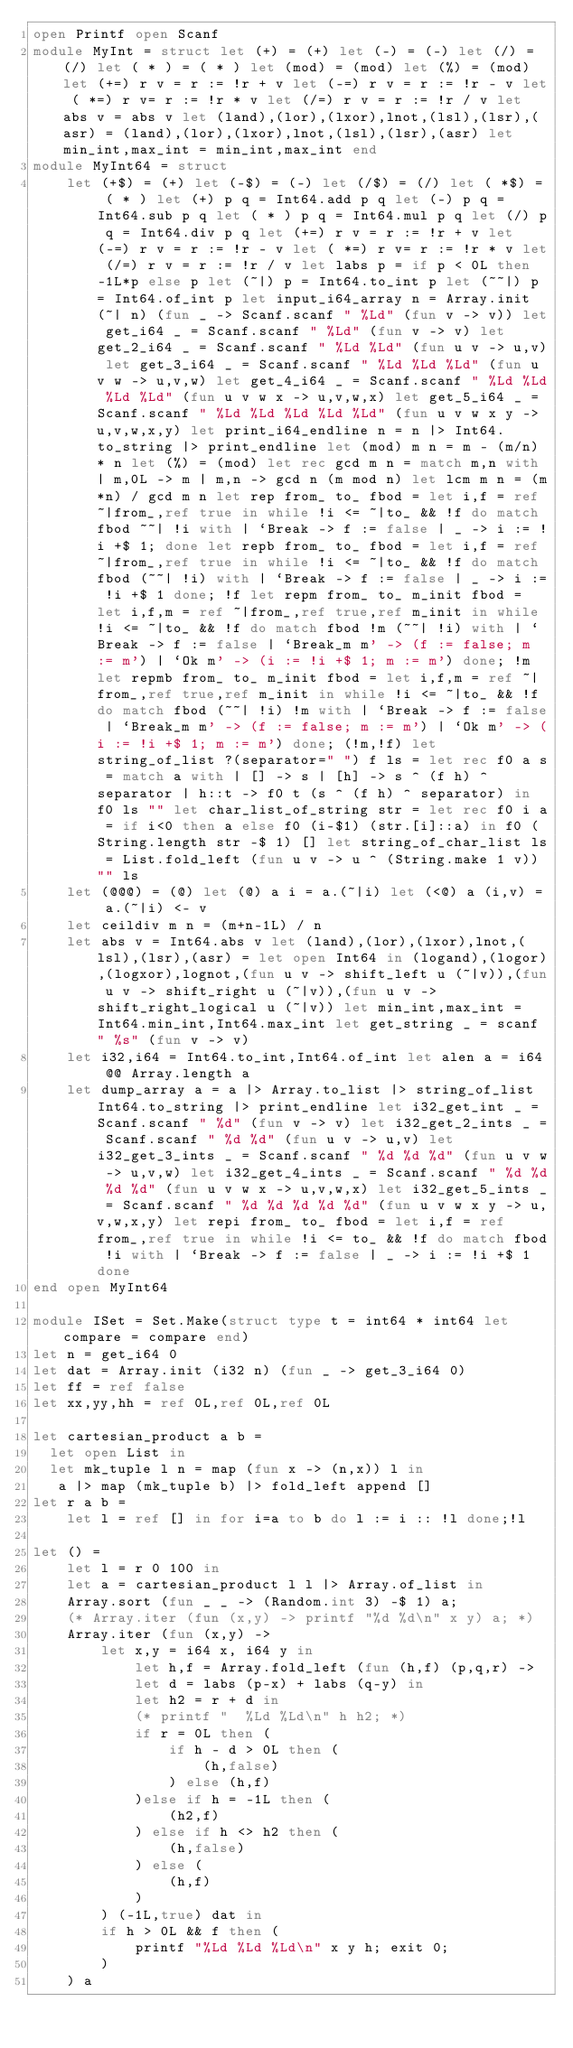<code> <loc_0><loc_0><loc_500><loc_500><_OCaml_>open Printf open Scanf
module MyInt = struct let (+) = (+) let (-) = (-) let (/) = (/) let ( * ) = ( * ) let (mod) = (mod) let (%) = (mod) let (+=) r v = r := !r + v let (-=) r v = r := !r - v let ( *=) r v= r := !r * v let (/=) r v = r := !r / v let abs v = abs v let (land),(lor),(lxor),lnot,(lsl),(lsr),(asr) = (land),(lor),(lxor),lnot,(lsl),(lsr),(asr) let min_int,max_int = min_int,max_int end
module MyInt64 = struct
	let (+$) = (+) let (-$) = (-) let (/$) = (/) let ( *$) = ( * ) let (+) p q = Int64.add p q let (-) p q = Int64.sub p q let ( * ) p q = Int64.mul p q let (/) p q = Int64.div p q let (+=) r v = r := !r + v let (-=) r v = r := !r - v let ( *=) r v= r := !r * v let (/=) r v = r := !r / v let labs p = if p < 0L then -1L*p else p let (~|) p = Int64.to_int p let (~~|) p = Int64.of_int p let input_i64_array n = Array.init (~| n) (fun _ -> Scanf.scanf " %Ld" (fun v -> v)) let get_i64 _ = Scanf.scanf " %Ld" (fun v -> v) let get_2_i64 _ = Scanf.scanf " %Ld %Ld" (fun u v -> u,v) let get_3_i64 _ = Scanf.scanf " %Ld %Ld %Ld" (fun u v w -> u,v,w) let get_4_i64 _ = Scanf.scanf " %Ld %Ld %Ld %Ld" (fun u v w x -> u,v,w,x) let get_5_i64 _ = Scanf.scanf " %Ld %Ld %Ld %Ld %Ld" (fun u v w x y -> u,v,w,x,y) let print_i64_endline n = n |> Int64.to_string |> print_endline let (mod) m n = m - (m/n) * n let (%) = (mod) let rec gcd m n = match m,n with | m,0L -> m | m,n -> gcd n (m mod n) let lcm m n = (m*n) / gcd m n let rep from_ to_ fbod = let i,f = ref ~|from_,ref true in while !i <= ~|to_ && !f do match fbod ~~| !i with | `Break -> f := false | _ -> i := !i +$ 1; done let repb from_ to_ fbod = let i,f = ref ~|from_,ref true in while !i <= ~|to_ && !f do match fbod (~~| !i) with | `Break -> f := false | _ -> i := !i +$ 1 done; !f let repm from_ to_ m_init fbod = let i,f,m = ref ~|from_,ref true,ref m_init in while !i <= ~|to_ && !f do match fbod !m (~~| !i) with | `Break -> f := false | `Break_m m' -> (f := false; m := m') | `Ok m' -> (i := !i +$ 1; m := m') done; !m let repmb from_ to_ m_init fbod = let i,f,m = ref ~|from_,ref true,ref m_init in while !i <= ~|to_ && !f do match fbod (~~| !i) !m with | `Break -> f := false | `Break_m m' -> (f := false; m := m') | `Ok m' -> (i := !i +$ 1; m := m') done; (!m,!f) let string_of_list ?(separator=" ") f ls = let rec f0 a s = match a with | [] -> s | [h] -> s ^ (f h) ^ separator | h::t -> f0 t (s ^ (f h) ^ separator) in f0 ls "" let char_list_of_string str = let rec f0 i a = if i<0 then a else f0 (i-$1) (str.[i]::a) in f0 (String.length str -$ 1) [] let string_of_char_list ls = List.fold_left (fun u v -> u ^ (String.make 1 v)) "" ls
	let (@@@) = (@) let (@) a i = a.(~|i) let (<@) a (i,v) = a.(~|i) <- v
	let ceildiv m n = (m+n-1L) / n
	let abs v = Int64.abs v let (land),(lor),(lxor),lnot,(lsl),(lsr),(asr) = let open Int64 in (logand),(logor),(logxor),lognot,(fun u v -> shift_left u (~|v)),(fun u v -> shift_right u (~|v)),(fun u v -> shift_right_logical u (~|v)) let min_int,max_int = Int64.min_int,Int64.max_int let get_string _ = scanf " %s" (fun v -> v)
	let i32,i64 = Int64.to_int,Int64.of_int let alen a = i64 @@ Array.length a
	let dump_array a = a |> Array.to_list |> string_of_list Int64.to_string |> print_endline let i32_get_int _ = Scanf.scanf " %d" (fun v -> v) let i32_get_2_ints _ = Scanf.scanf " %d %d" (fun u v -> u,v) let i32_get_3_ints _ = Scanf.scanf " %d %d %d" (fun u v w -> u,v,w) let i32_get_4_ints _ = Scanf.scanf " %d %d %d %d" (fun u v w x -> u,v,w,x) let i32_get_5_ints _ = Scanf.scanf " %d %d %d %d %d" (fun u v w x y -> u,v,w,x,y) let repi from_ to_ fbod = let i,f = ref from_,ref true in while !i <= to_ && !f do match fbod !i with | `Break -> f := false | _ -> i := !i +$ 1 done
end open MyInt64

module ISet = Set.Make(struct type t = int64 * int64 let compare = compare end)
let n = get_i64 0
let dat = Array.init (i32 n) (fun _ -> get_3_i64 0) 
let ff = ref false 
let xx,yy,hh = ref 0L,ref 0L,ref 0L 

let cartesian_product a b =
  let open List in
  let mk_tuple l n = map (fun x -> (n,x)) l in  
   a |> map (mk_tuple b) |> fold_left append []
let r a b =
	let l = ref [] in for i=a to b do l := i :: !l done;!l

let () =
	let l = r 0 100 in
	let a = cartesian_product l l |> Array.of_list in
	Array.sort (fun _ _ -> (Random.int 3) -$ 1) a;
	(* Array.iter (fun (x,y) -> printf "%d %d\n" x y) a; *)
	Array.iter (fun (x,y) ->
		let x,y = i64 x, i64 y in
			let h,f = Array.fold_left (fun (h,f) (p,q,r) ->
			let d = labs (p-x) + labs (q-y) in
			let h2 = r + d in
			(* printf "  %Ld %Ld\n" h h2; *)
			if r = 0L then (
				if h - d > 0L then (
					(h,false)
				) else (h,f)
			)else if h = -1L then (
				(h2,f)
			) else if h <> h2 then (
				(h,false)
			) else (
				(h,f)
			)
		) (-1L,true) dat in
		if h > 0L && f then (
			printf "%Ld %Ld %Ld\n" x y h; exit 0;
		)
	) a</code> 